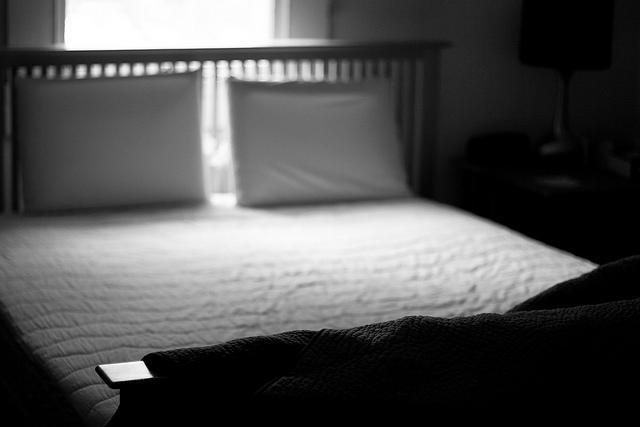How many pillows are on the bed?
Give a very brief answer. 2. 